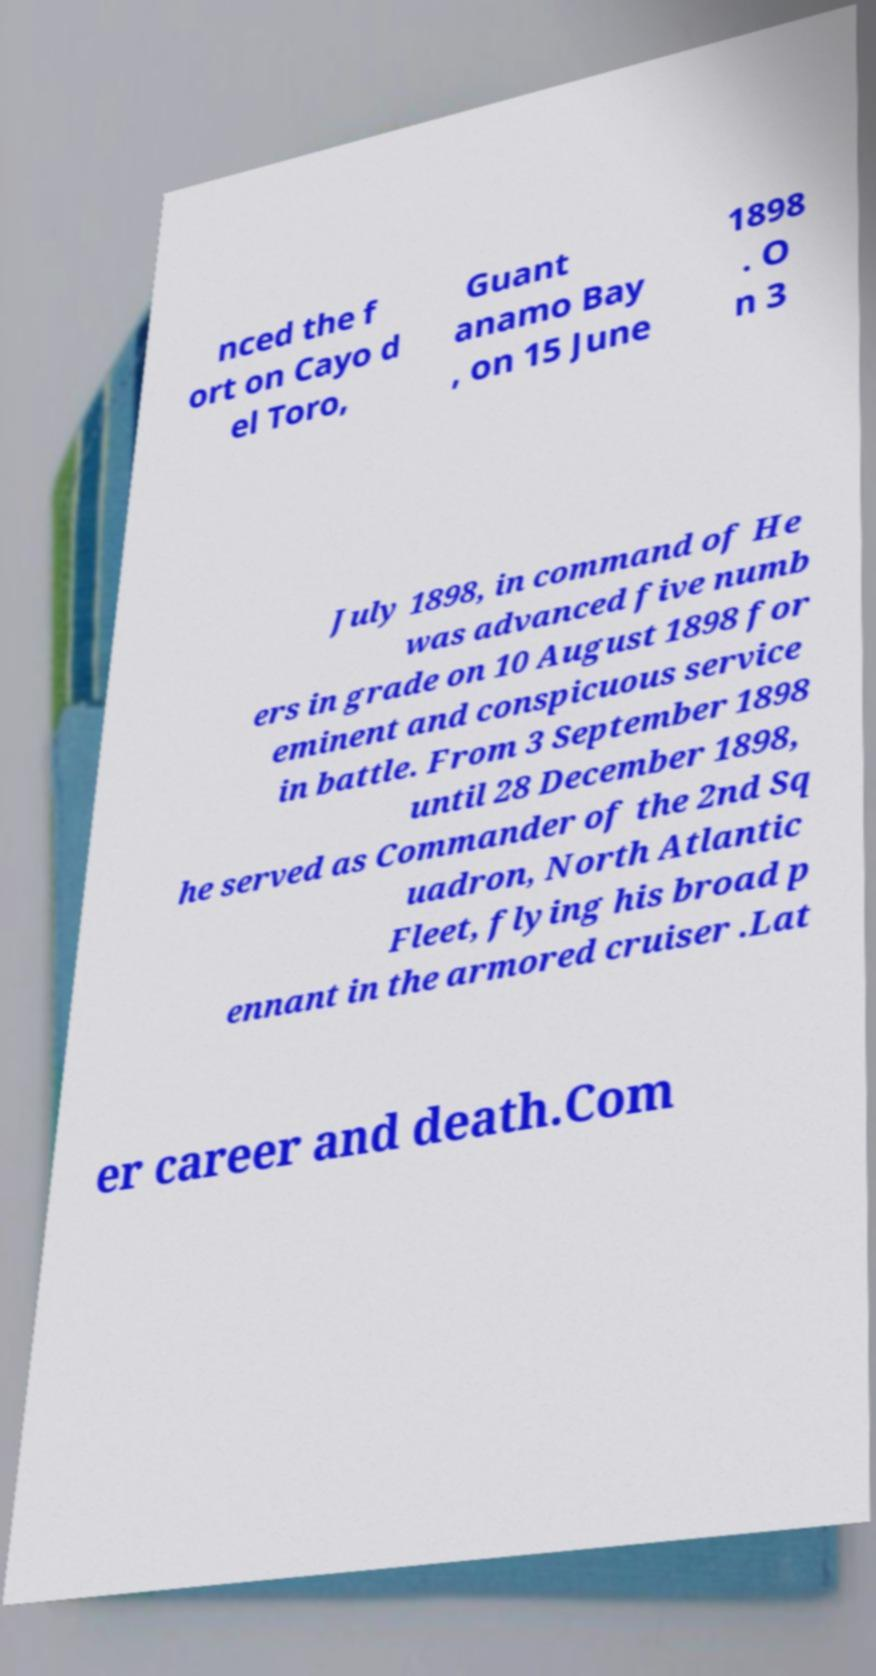Could you assist in decoding the text presented in this image and type it out clearly? nced the f ort on Cayo d el Toro, Guant anamo Bay , on 15 June 1898 . O n 3 July 1898, in command of He was advanced five numb ers in grade on 10 August 1898 for eminent and conspicuous service in battle. From 3 September 1898 until 28 December 1898, he served as Commander of the 2nd Sq uadron, North Atlantic Fleet, flying his broad p ennant in the armored cruiser .Lat er career and death.Com 